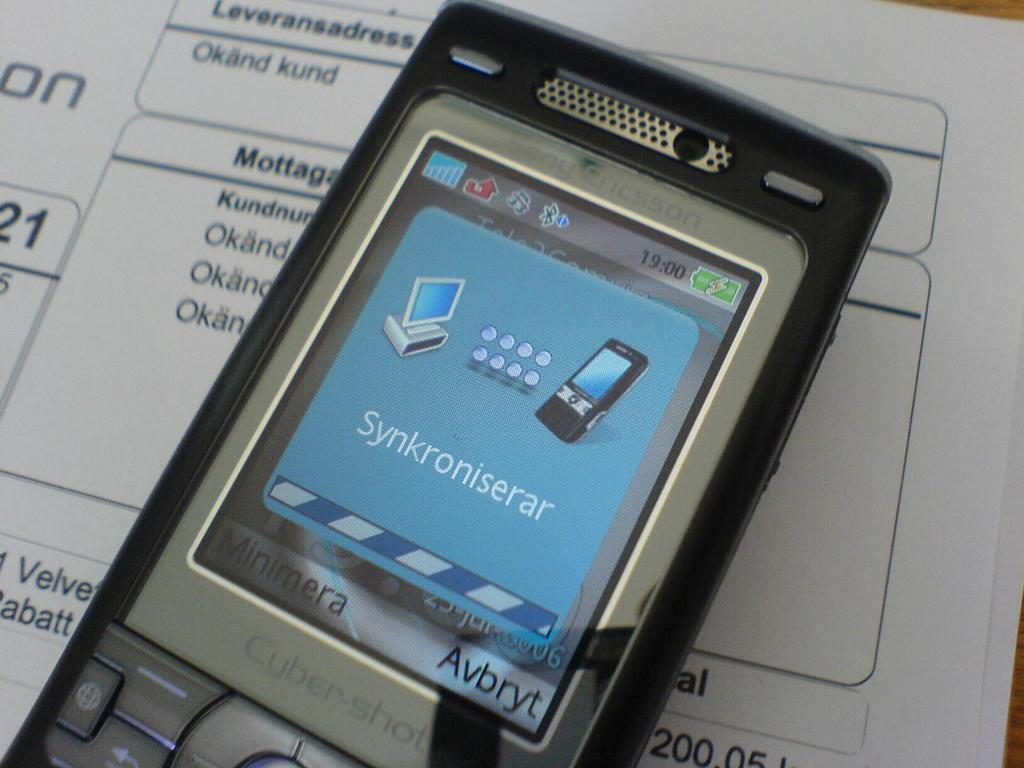<image>
Summarize the visual content of the image. A phone screen showing the word Synkroniserar on it 